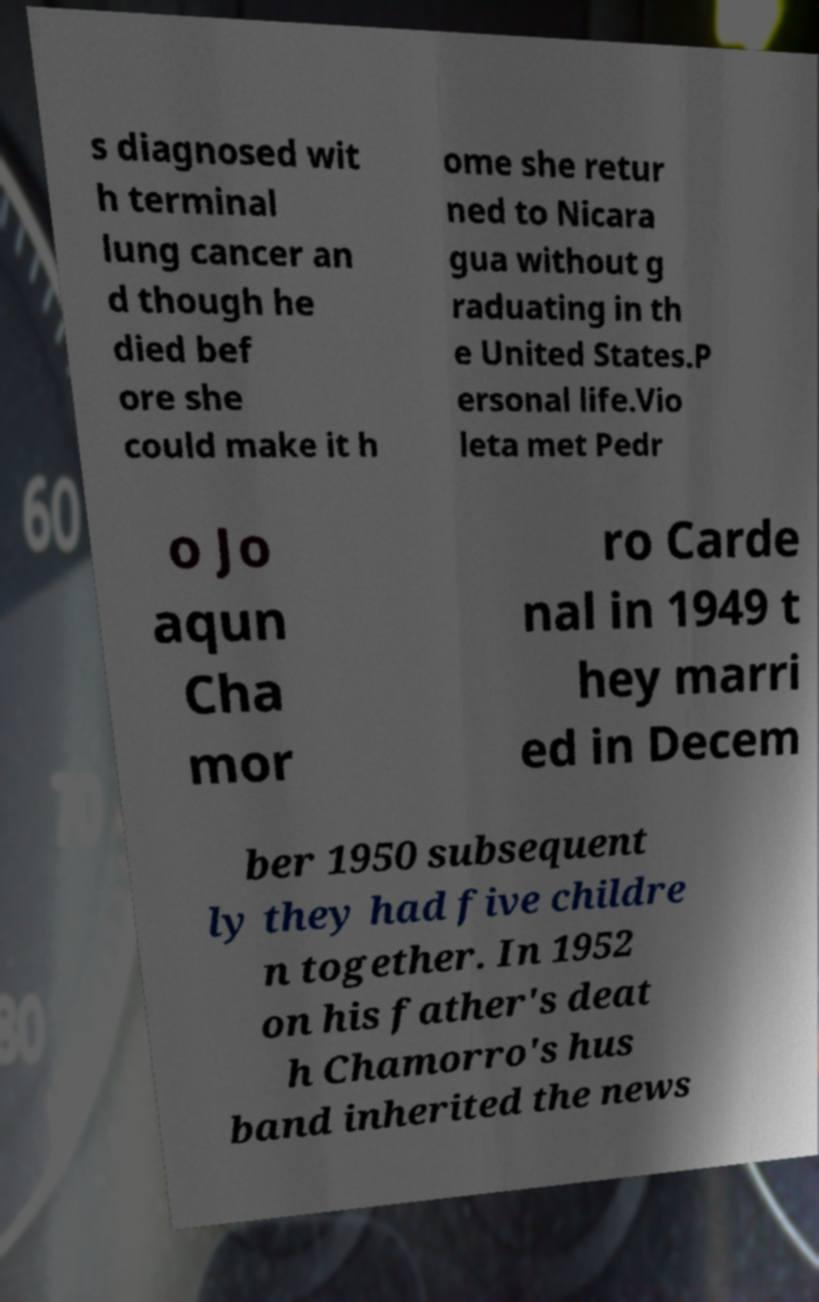Please identify and transcribe the text found in this image. s diagnosed wit h terminal lung cancer an d though he died bef ore she could make it h ome she retur ned to Nicara gua without g raduating in th e United States.P ersonal life.Vio leta met Pedr o Jo aqun Cha mor ro Carde nal in 1949 t hey marri ed in Decem ber 1950 subsequent ly they had five childre n together. In 1952 on his father's deat h Chamorro's hus band inherited the news 